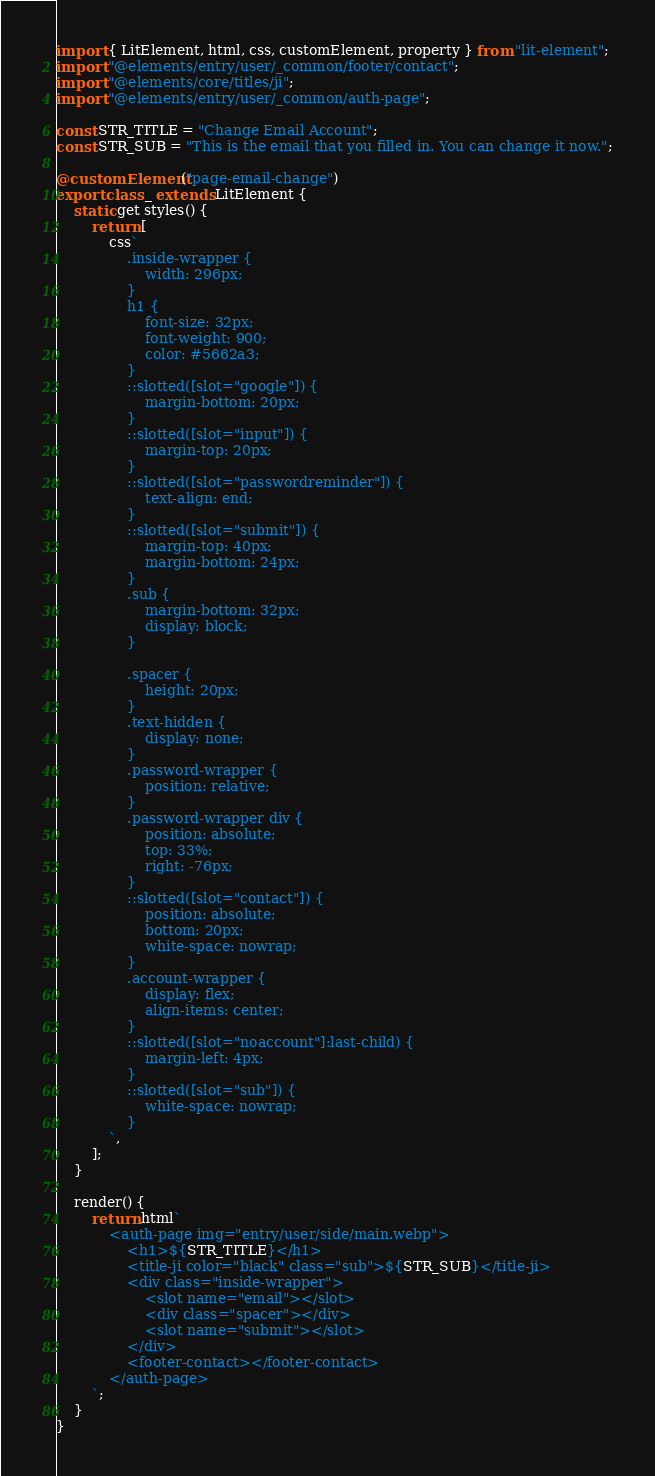Convert code to text. <code><loc_0><loc_0><loc_500><loc_500><_TypeScript_>import { LitElement, html, css, customElement, property } from "lit-element";
import "@elements/entry/user/_common/footer/contact";
import "@elements/core/titles/ji";
import "@elements/entry/user/_common/auth-page";

const STR_TITLE = "Change Email Account";
const STR_SUB = "This is the email that you filled in. You can change it now.";

@customElement("page-email-change")
export class _ extends LitElement {
    static get styles() {
        return [
            css`
                .inside-wrapper {
                    width: 296px;
                }
                h1 {
                    font-size: 32px;
                    font-weight: 900;
                    color: #5662a3;
                }
                ::slotted([slot="google"]) {
                    margin-bottom: 20px;
                }
                ::slotted([slot="input"]) {
                    margin-top: 20px;
                }
                ::slotted([slot="passwordreminder"]) {
                    text-align: end;
                }
                ::slotted([slot="submit"]) {
                    margin-top: 40px;
                    margin-bottom: 24px;
                }
                .sub {
                    margin-bottom: 32px;
                    display: block;
                }

                .spacer {
                    height: 20px;
                }
                .text-hidden {
                    display: none;
                }
                .password-wrapper {
                    position: relative;
                }
                .password-wrapper div {
                    position: absolute;
                    top: 33%;
                    right: -76px;
                }
                ::slotted([slot="contact"]) {
                    position: absolute;
                    bottom: 20px;
                    white-space: nowrap;
                }
                .account-wrapper {
                    display: flex;
                    align-items: center;
                }
                ::slotted([slot="noaccount"]:last-child) {
                    margin-left: 4px;
                }
                ::slotted([slot="sub"]) {
                    white-space: nowrap;
                }
            `,
        ];
    }

    render() {
        return html`
            <auth-page img="entry/user/side/main.webp">
                <h1>${STR_TITLE}</h1>
                <title-ji color="black" class="sub">${STR_SUB}</title-ji>
                <div class="inside-wrapper">
                    <slot name="email"></slot>
                    <div class="spacer"></div>
                    <slot name="submit"></slot>
                </div>
                <footer-contact></footer-contact>
            </auth-page>
        `;
    }
}
</code> 